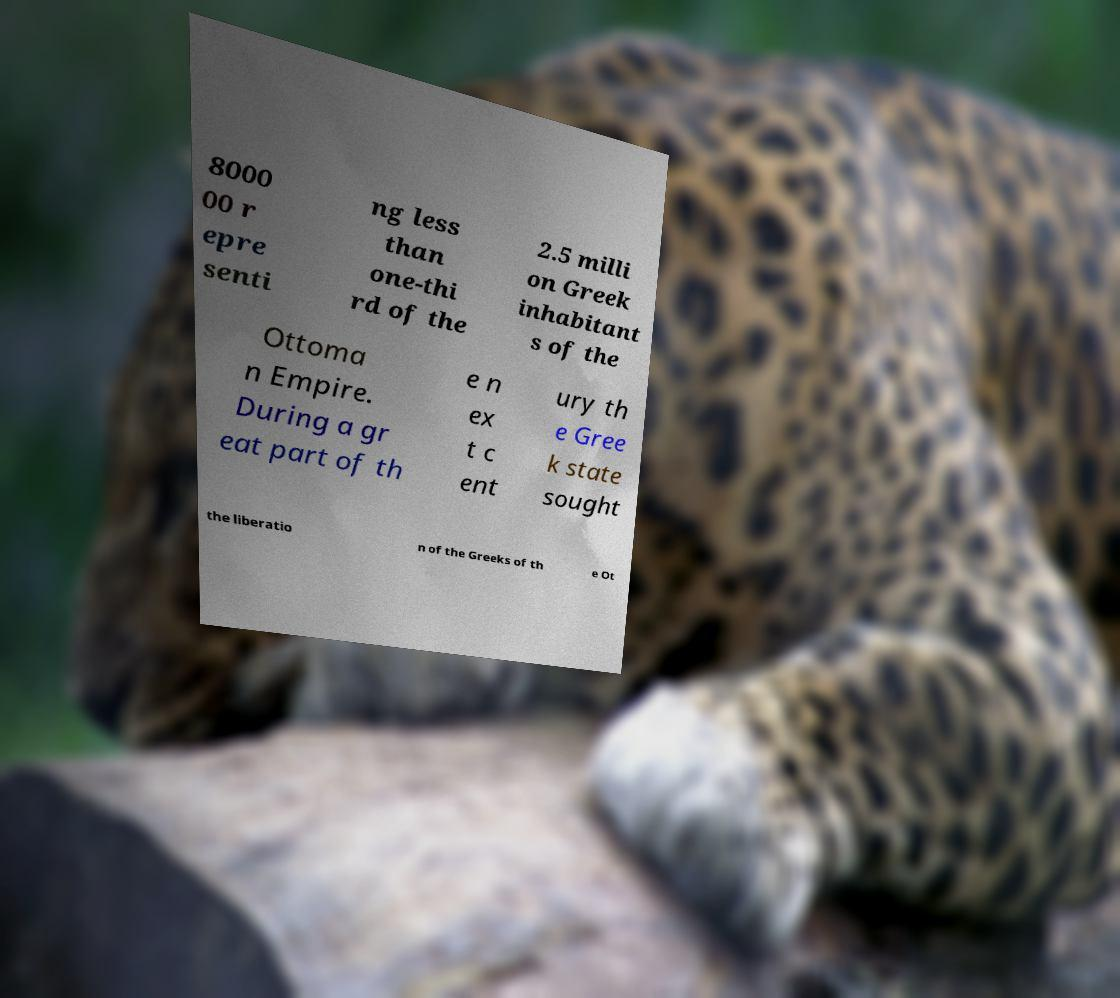Could you extract and type out the text from this image? 8000 00 r epre senti ng less than one-thi rd of the 2.5 milli on Greek inhabitant s of the Ottoma n Empire. During a gr eat part of th e n ex t c ent ury th e Gree k state sought the liberatio n of the Greeks of th e Ot 